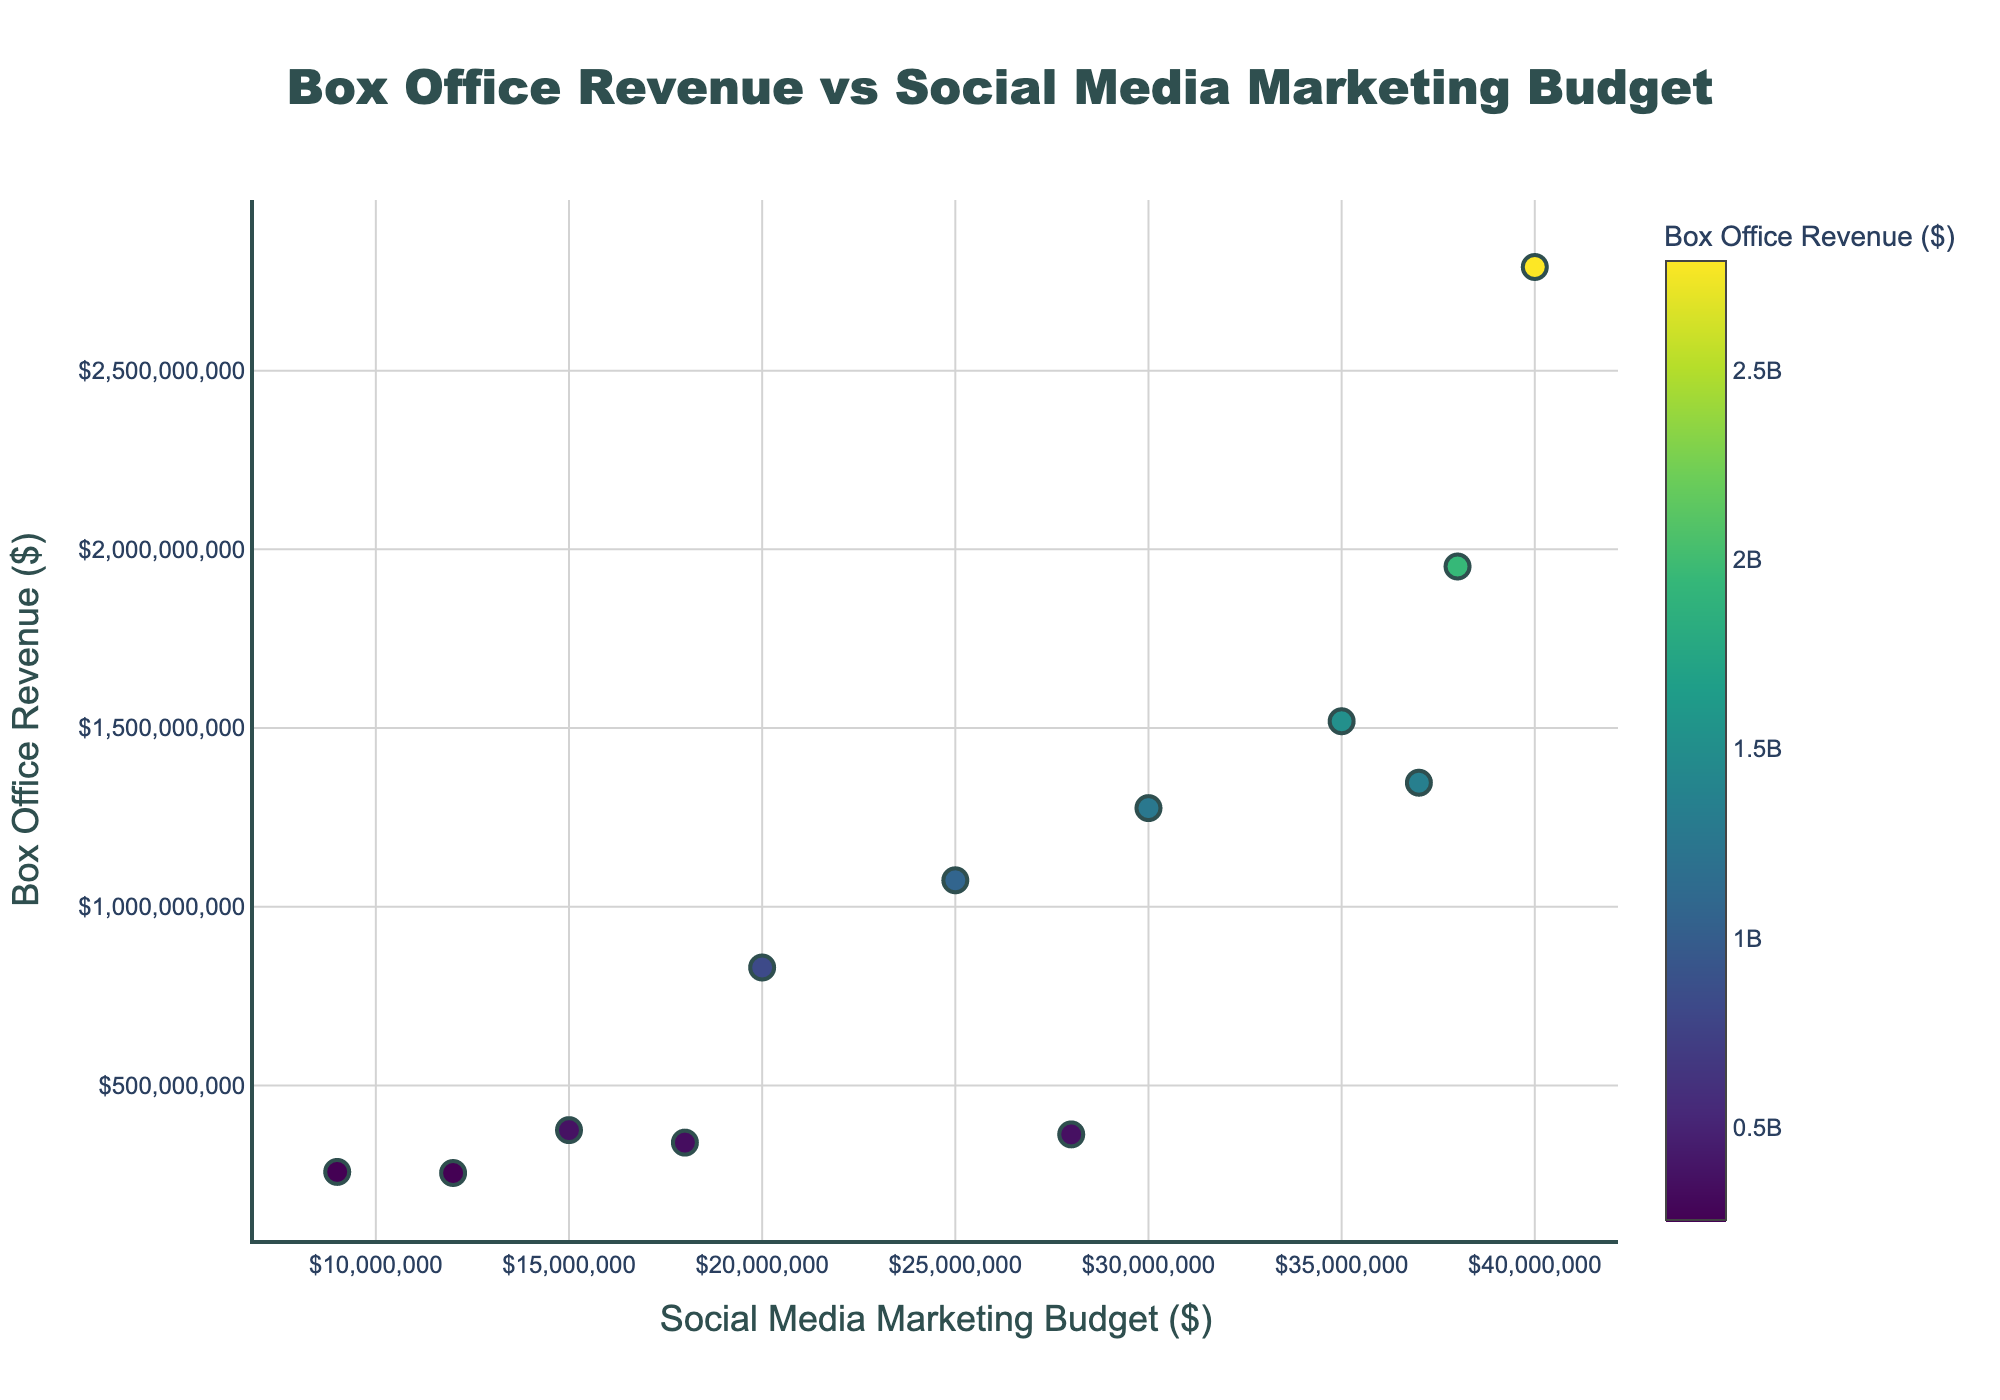What is the title of the figure? The title is located at the top center of the figure. It should clearly indicate what the figure is about.
Answer: Box Office Revenue vs Social Media Marketing Budget How many films are represented in the scatter plot? Count the number of markers (dots) in the scatter plot. Each marker represents one film.
Answer: 12 Which film has the highest social media marketing budget? Identify the highest value on the x-axis (Social Media Budget) and find the corresponding film's marker.
Answer: Avatar What is the social media marketing budget for "Parasite"? Find the marker corresponding to "Parasite" and check its position on the x-axis.
Answer: $9,000,000 Which film has the lowest box office revenue among those with a social media marketing budget of more than $30,000,000? Identify films with social media marketing budgets higher than $30,000,000 and compare their positions on the y-axis.
Answer: Frozen What is the range of the margin of error for the film "Joker"? Look for the error bar length for the film "Joker" to determine the range of its margin of error.
Answer: ±$6,000,000 Which film has the smallest margin of error? Identify the shortest error bars in the figure and find the corresponding film's marker.
Answer: Parasite How does the box office revenue of "Inception" compare to that of "Frozen"? Compare the y-axis positions of the markers for "Inception" and "Frozen".
Answer: Inception has lower box office revenue than Frozen What's the total box office revenue for films with a social media marketing budget less than $20,000,000? Identify films with social media marketing budgets below $20,000,000 and sum up their y-axis values.
Answer: $2,058,000,000 Are there any films with the same box office revenue but different social media marketing budgets? Look for markers aligned horizontally having different x-axis positions.
Answer: No 